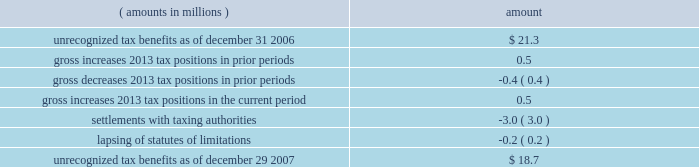Notes to consolidated financial statements ( continued ) | 72 snap-on incorporated following is a reconciliation of the beginning and ending amount of unrecognized tax benefits : ( amounts in millions ) amount .
Of the $ 18.7 million of unrecognized tax benefits at the end of 2007 , approximately $ 16.2 million would impact the effective income tax rate if recognized .
Interest and penalties related to unrecognized tax benefits are recorded in income tax expense .
During the years ended december 29 , 2007 , december 30 , 2006 , and december 31 , 2005 , the company recognized approximately $ 1.2 million , $ 0.5 million and ( $ 0.5 ) million in net interest expense ( benefit ) , respectively .
The company has provided for approximately $ 3.4 million , $ 2.2 million , and $ 1.7 million of accrued interest related to unrecognized tax benefits at the end of fiscal year 2007 , 2006 and 2005 , respectively .
During the next 12 months , the company does not anticipate any significant changes to the total amount of unrecognized tax benefits , other than the accrual of additional interest expense in an amount similar to the prior year 2019s expense .
With few exceptions , snap-on is no longer subject to u.s .
Federal and state/local income tax examinations by tax authorities for years prior to 2003 , and snap-on is no longer subject to non-u.s .
Income tax examinations by tax authorities for years prior to 2001 .
The undistributed earnings of all non-u.s .
Subsidiaries totaled $ 338.5 million , $ 247.4 million and $ 173.6 million at the end of fiscal 2007 , 2006 and 2005 , respectively .
Snap-on has not provided any deferred taxes on these undistributed earnings as it considers the undistributed earnings to be permanently invested .
Determination of the amount of unrecognized deferred income tax liability related to these earnings is not practicable .
The american jobs creation act of 2004 ( the 201cajca 201d ) created a one-time tax incentive for u.s .
Corporations to repatriate accumulated foreign earnings by providing a tax deduction of 85% ( 85 % ) of qualifying dividends received from foreign affiliates .
Under the provisions of the ajca , snap-on repatriated approximately $ 93 million of qualifying dividends in 2005 that resulted in additional income tax expense of $ 3.3 million for the year .
Note 9 : short-term and long-term debt notes payable and long-term debt as of december 29 , 2007 , was $ 517.9 million ; no commercial paper was outstanding at december 29 , 2007 .
As of december 30 , 2006 , notes payable and long-term debt was $ 549.2 million , including $ 314.9 million of commercial paper .
Snap-on presented $ 300 million of the december 30 , 2006 , outstanding commercial paper as 201clong-term debt 201d on the accompanying december 30 , 2006 , consolidated balance sheet .
On january 12 , 2007 , snap-on sold $ 300 million of unsecured notes consisting of $ 150 million of floating rate notes that mature on january 12 , 2010 , and $ 150 million of fixed rate notes that mature on january 15 , 2017 .
Interest on the floating rate notes accrues at a rate equal to the three-month london interbank offer rate plus 0.13% ( 0.13 % ) per year and is payable quarterly .
Interest on the fixed rate notes accrues at a rate of 5.50% ( 5.50 % ) per year and is payable semi-annually .
Snap-on used the proceeds from the sale of the notes , net of $ 1.5 million of transaction costs , to repay commercial paper obligations issued to finance the acquisition of business solutions .
On january 12 , 2007 , the company also terminated a $ 250 million bridge credit agreement that snap-on established prior to its acquisition of business solutions. .
What was the average undistributed earnings of all non-u.s.subsidiaries from 2005 to 2007? 
Computations: (((173.6 + (338.5 + 247.4)) + 3) / 2)
Answer: 381.25. 